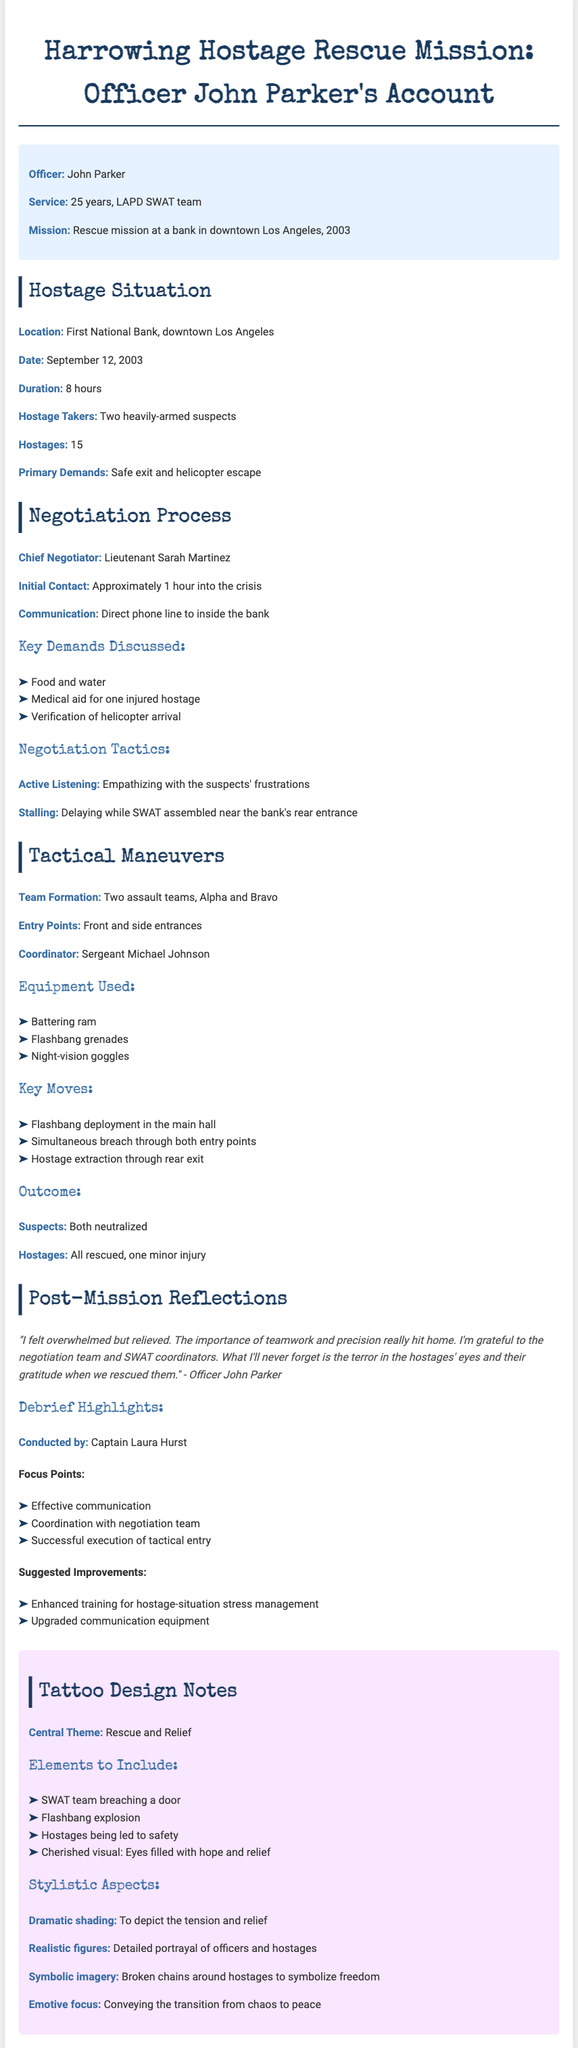What was the location of the hostage situation? The document mentions that the hostage situation took place at the First National Bank in downtown Los Angeles.
Answer: First National Bank, downtown Los Angeles Who was the chief negotiator? The chief negotiator identified in the document is Lieutenant Sarah Martinez.
Answer: Lieutenant Sarah Martinez How many hostages were involved in the situation? According to the document, there were 15 hostages involved in the hostage situation.
Answer: 15 What was the primary demand of the hostage takers? The document states that the primary demands included a safe exit and helicopter escape.
Answer: Safe exit and helicopter escape What equipment was used during the tactical maneuvers? The document lists that a battering ram, flashbang grenades, and night-vision goggles were used.
Answer: Battering ram, flashbang grenades, night-vision goggles What was the duration of the hostage situation? The document specifies that the duration of the hostage situation was 8 hours.
Answer: 8 hours What is the central theme suggested for the tattoo design? The document indicates that the central theme for the tattoo design is "Rescue and Relief."
Answer: Rescue and Relief What was Officer John Parker's reflection on the experience? Officer John Parker felt overwhelmed but relieved, highlighting the importance of teamwork.
Answer: Overwhelmed but relieved What symbolic imagery is suggested for the tattoo design? The document describes "broken chains around hostages" as a symbolic imagery to represent freedom.
Answer: Broken chains around hostages 